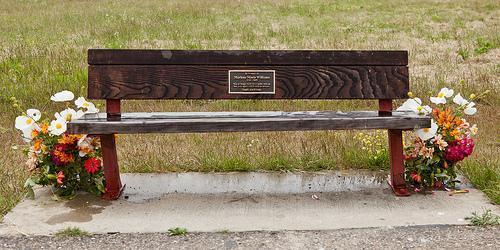How many flowers arrangements are there?
Give a very brief answer. 2. 